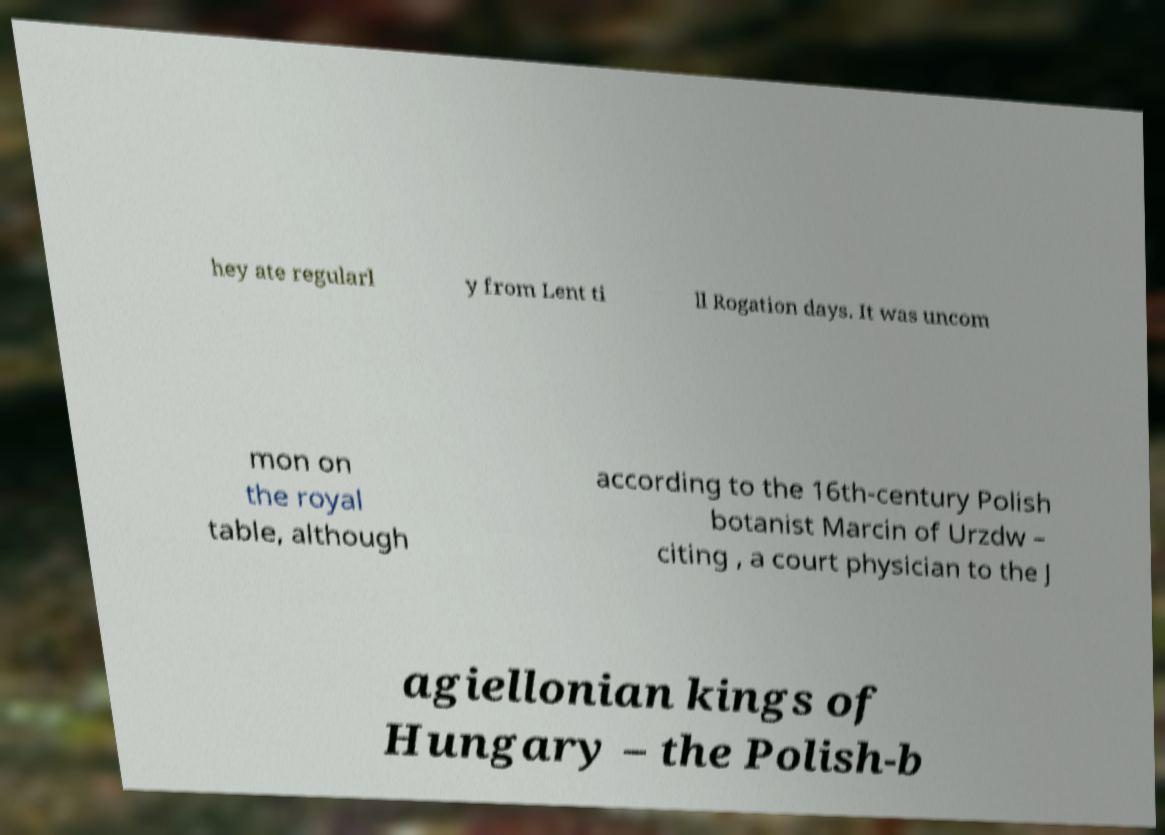Please identify and transcribe the text found in this image. hey ate regularl y from Lent ti ll Rogation days. It was uncom mon on the royal table, although according to the 16th-century Polish botanist Marcin of Urzdw – citing , a court physician to the J agiellonian kings of Hungary – the Polish-b 